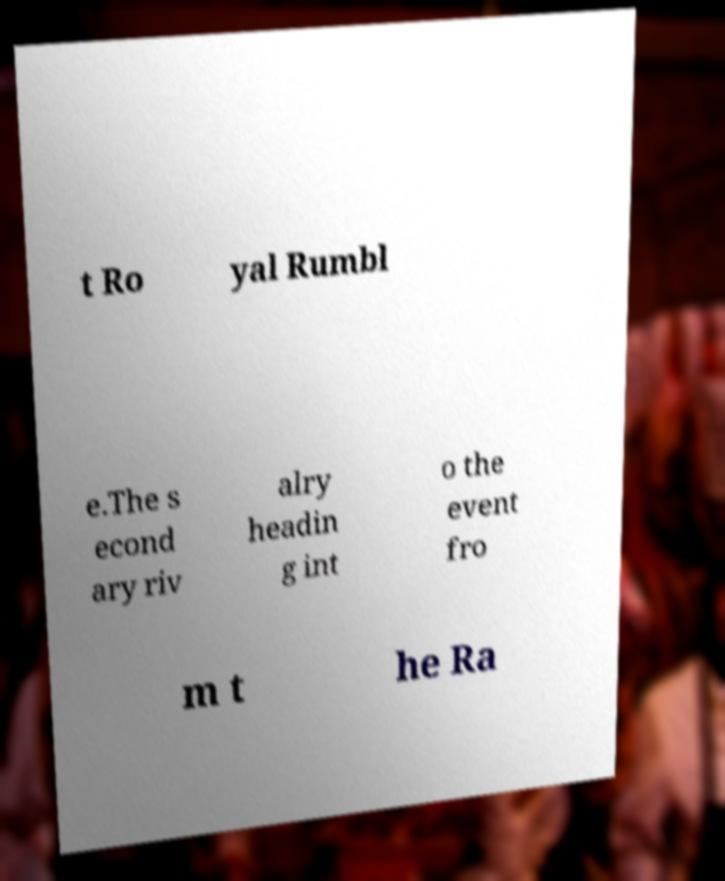What messages or text are displayed in this image? I need them in a readable, typed format. t Ro yal Rumbl e.The s econd ary riv alry headin g int o the event fro m t he Ra 